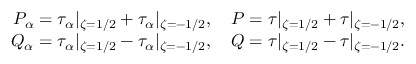Convert formula to latex. <formula><loc_0><loc_0><loc_500><loc_500>\begin{array} { r } { P _ { \alpha } = \tau _ { \alpha } | _ { \zeta = 1 / 2 } + \tau _ { \alpha } | _ { \zeta = - 1 / 2 } , \quad P = \tau | _ { \zeta = 1 / 2 } + \tau | _ { \zeta = - 1 / 2 } , } \\ { Q _ { \alpha } = \tau _ { \alpha } | _ { \zeta = 1 / 2 } - \tau _ { \alpha } | _ { \zeta = - 1 / 2 } , \quad Q = \tau | _ { \zeta = 1 / 2 } - \tau | _ { \zeta = - 1 / 2 } . } \end{array}</formula> 